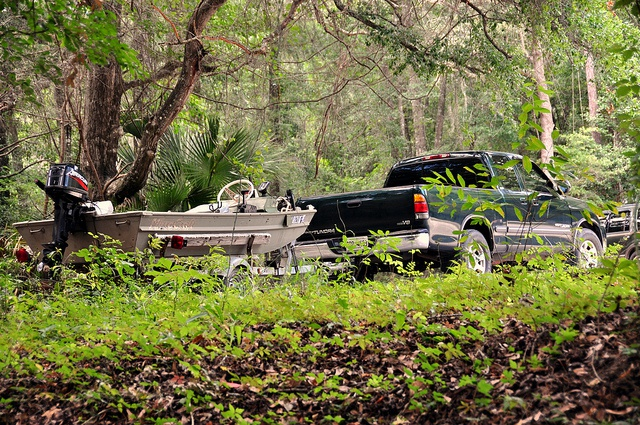Describe the objects in this image and their specific colors. I can see truck in darkgreen, black, gray, darkgray, and lightgray tones and boat in darkgreen, black, darkgray, and gray tones in this image. 